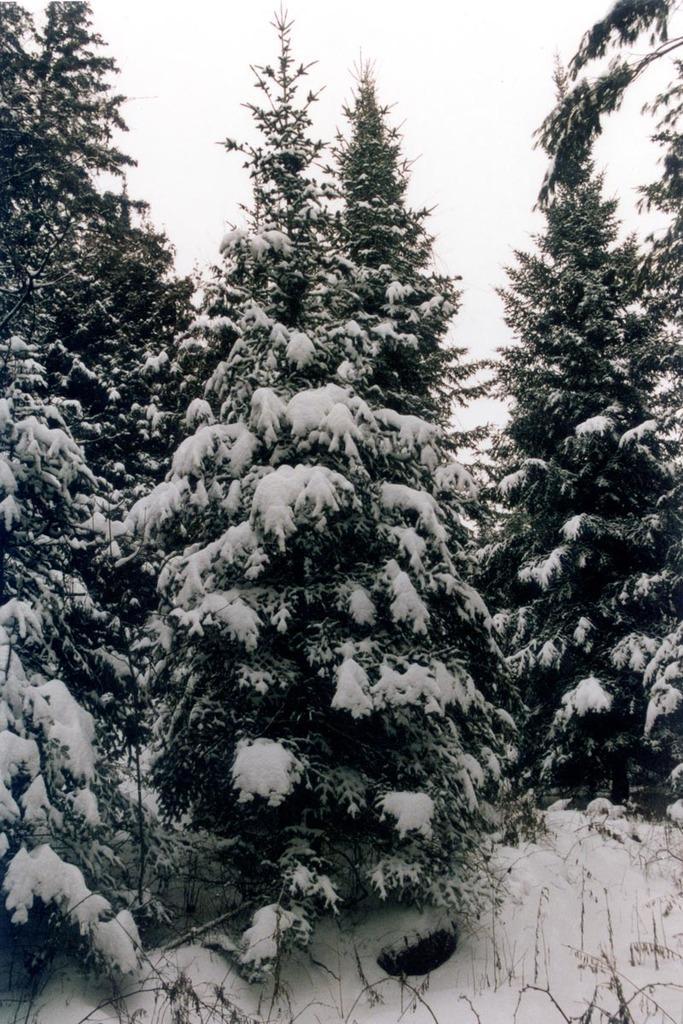Could you give a brief overview of what you see in this image? In this image I can see few trees and the snow. The sky is in white color. 